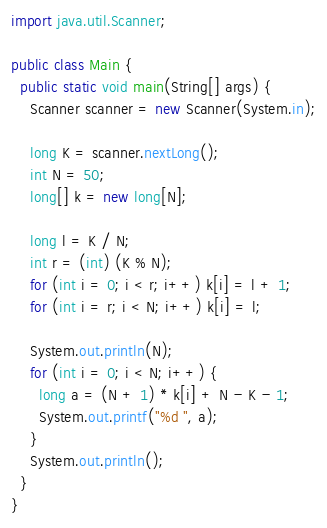<code> <loc_0><loc_0><loc_500><loc_500><_Java_>import java.util.Scanner;

public class Main {
  public static void main(String[] args) {
    Scanner scanner = new Scanner(System.in);

    long K = scanner.nextLong();
    int N = 50;
    long[] k = new long[N];

    long l = K / N;
    int r = (int) (K % N);
    for (int i = 0; i < r; i++) k[i] = l + 1;
    for (int i = r; i < N; i++) k[i] = l;

    System.out.println(N);
    for (int i = 0; i < N; i++) {
      long a = (N + 1) * k[i] + N - K - 1;
      System.out.printf("%d ", a);
    }
    System.out.println();
  }
}
</code> 